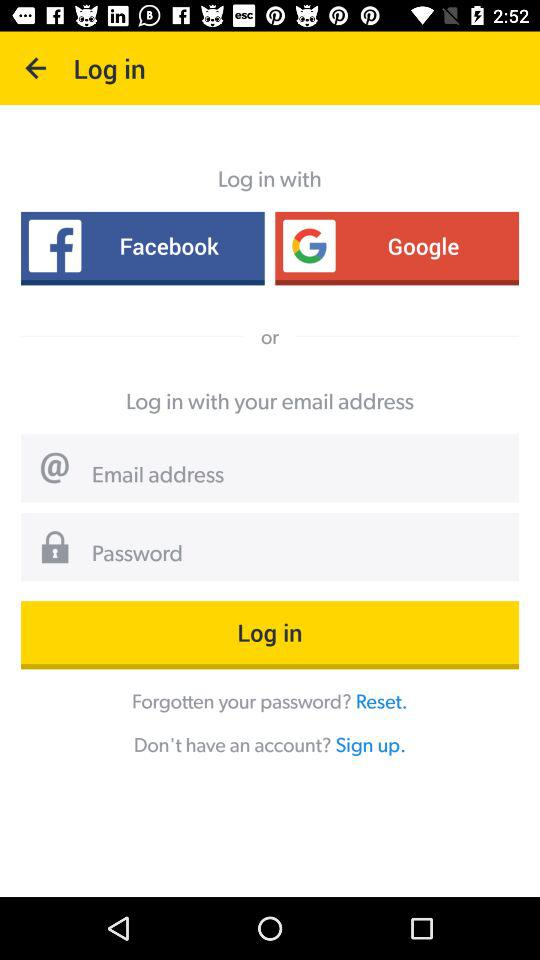What should I do if I forget my password? You should have to reset the password. 